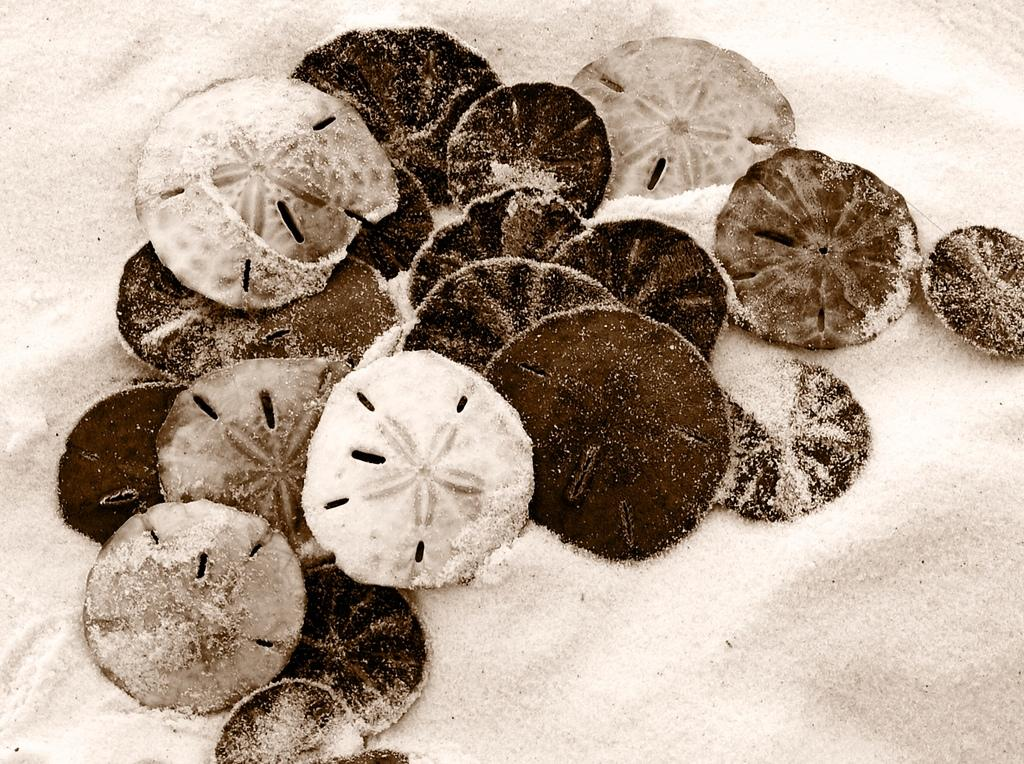What is the main subject of the image? The main subject of the image is sand dollars. Where are the sand dollars located in the image? The sand dollars are in the center of the image. What can be seen in the background of the image? There is soil visible in the background of the image. How many parcels are placed on the table in the image? There is no table or parcel present in the image; it only features sand dollars and soil in the background. 